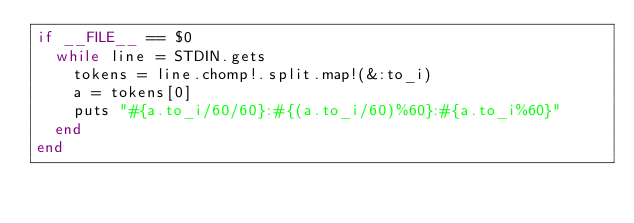<code> <loc_0><loc_0><loc_500><loc_500><_Ruby_>if __FILE__ == $0
  while line = STDIN.gets
    tokens = line.chomp!.split.map!(&:to_i)
    a = tokens[0]
    puts "#{a.to_i/60/60}:#{(a.to_i/60)%60}:#{a.to_i%60}"
  end
end</code> 